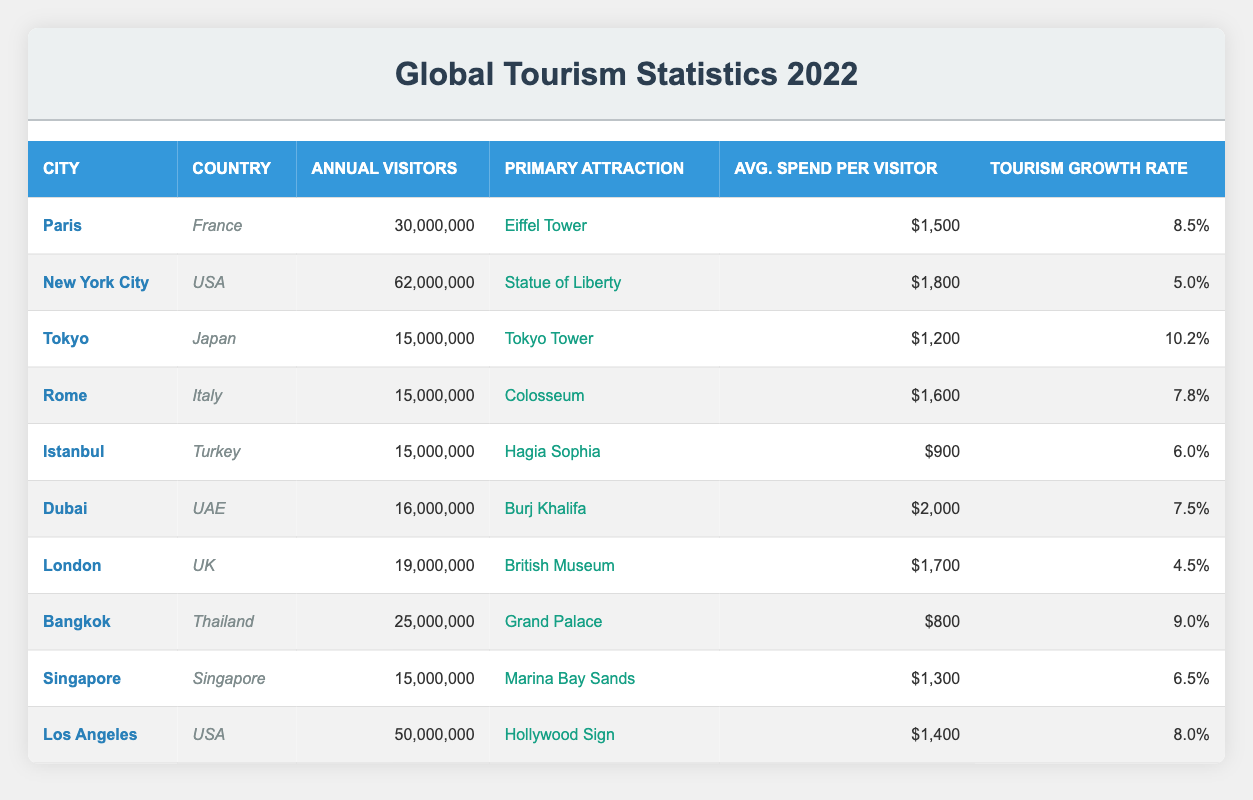What city had the highest number of annual visitors in 2022? By looking at the "Annual Visitors" column, New York City has 62,000,000, which is higher than any other city listed.
Answer: New York City Which city's primary attraction is the Burj Khalifa? The table shows that Dubai has the Burj Khalifa as its primary attraction.
Answer: Dubai How much did visitors on average spend in Los Angeles? The "Avg. Spend per Visitor" column indicates that visitors in Los Angeles spent an average of $1,400.
Answer: $1,400 Was the tourism growth rate in Paris greater than that of London? By comparing the "Tourism Growth Rate" for Paris (8.5%) and London (4.5%), it is clear that Paris had a higher rate.
Answer: Yes What is the total number of annual visitors for the cities in the USA? By summing the annual visitors for New York City (62,000,000), Los Angeles (50,000,000), and those of other smaller cities listed in the table, the total is 112,000,000.
Answer: 112,000,000 Which city had the lowest average spend per visitor? The average spend per visitor in Istanbul is $900, which is the lowest when compared to other cities.
Answer: Istanbul Is Tokyo's tourism growth rate higher than Rome's? Comparing the rates; Tokyo has a tourism growth rate of 10.2%, while Rome has 7.8%, so Tokyo's growth is indeed higher.
Answer: Yes What is the average annual visitors for the cities listed? To find the average, sum the annual visitors (30,000,000 + 62,000,000 + 15,000,000 + 15,000,000 + 15,000,000 + 16,000,000 + 19,000,000 + 25,000,000 + 15,000,000 + 50,000,000 = 250,000,000) and divide by 10 (the number of cities), which results in 25,000,000.
Answer: 25,000,000 Which city is in Turkey and how many annual visitors did it attract? According to the "Country" column, Istanbul is the city from Turkey, with an annual visitor count of 15,000,000.
Answer: Istanbul, 15,000,000 